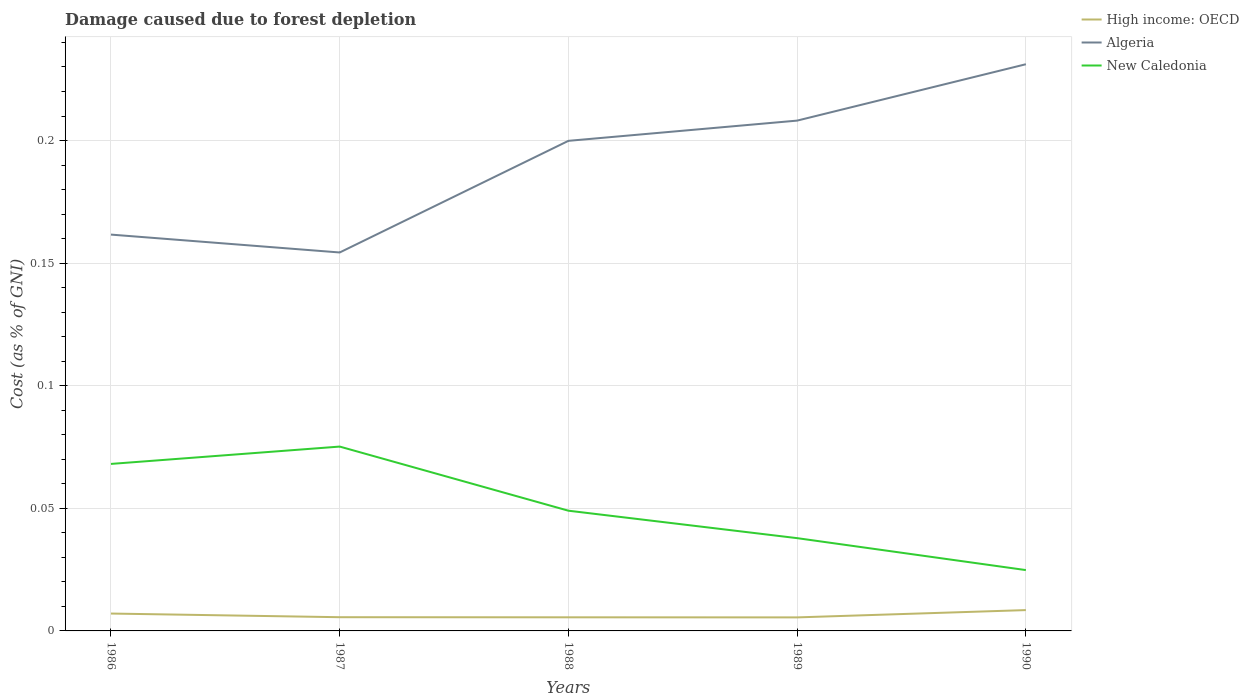Across all years, what is the maximum cost of damage caused due to forest depletion in High income: OECD?
Make the answer very short. 0.01. What is the total cost of damage caused due to forest depletion in High income: OECD in the graph?
Ensure brevity in your answer.  7.520586722561777e-5. What is the difference between the highest and the second highest cost of damage caused due to forest depletion in New Caledonia?
Give a very brief answer. 0.05. How many lines are there?
Keep it short and to the point. 3. How many years are there in the graph?
Provide a short and direct response. 5. What is the difference between two consecutive major ticks on the Y-axis?
Make the answer very short. 0.05. Does the graph contain any zero values?
Provide a succinct answer. No. How many legend labels are there?
Your answer should be very brief. 3. What is the title of the graph?
Offer a very short reply. Damage caused due to forest depletion. What is the label or title of the X-axis?
Make the answer very short. Years. What is the label or title of the Y-axis?
Provide a short and direct response. Cost (as % of GNI). What is the Cost (as % of GNI) of High income: OECD in 1986?
Your response must be concise. 0.01. What is the Cost (as % of GNI) of Algeria in 1986?
Offer a very short reply. 0.16. What is the Cost (as % of GNI) in New Caledonia in 1986?
Your answer should be very brief. 0.07. What is the Cost (as % of GNI) of High income: OECD in 1987?
Provide a succinct answer. 0.01. What is the Cost (as % of GNI) of Algeria in 1987?
Make the answer very short. 0.15. What is the Cost (as % of GNI) of New Caledonia in 1987?
Provide a succinct answer. 0.08. What is the Cost (as % of GNI) in High income: OECD in 1988?
Your answer should be compact. 0.01. What is the Cost (as % of GNI) of Algeria in 1988?
Ensure brevity in your answer.  0.2. What is the Cost (as % of GNI) in New Caledonia in 1988?
Your response must be concise. 0.05. What is the Cost (as % of GNI) of High income: OECD in 1989?
Keep it short and to the point. 0.01. What is the Cost (as % of GNI) of Algeria in 1989?
Ensure brevity in your answer.  0.21. What is the Cost (as % of GNI) of New Caledonia in 1989?
Provide a succinct answer. 0.04. What is the Cost (as % of GNI) of High income: OECD in 1990?
Make the answer very short. 0.01. What is the Cost (as % of GNI) in Algeria in 1990?
Your answer should be compact. 0.23. What is the Cost (as % of GNI) of New Caledonia in 1990?
Give a very brief answer. 0.02. Across all years, what is the maximum Cost (as % of GNI) of High income: OECD?
Provide a succinct answer. 0.01. Across all years, what is the maximum Cost (as % of GNI) in Algeria?
Give a very brief answer. 0.23. Across all years, what is the maximum Cost (as % of GNI) of New Caledonia?
Make the answer very short. 0.08. Across all years, what is the minimum Cost (as % of GNI) in High income: OECD?
Your response must be concise. 0.01. Across all years, what is the minimum Cost (as % of GNI) of Algeria?
Ensure brevity in your answer.  0.15. Across all years, what is the minimum Cost (as % of GNI) of New Caledonia?
Make the answer very short. 0.02. What is the total Cost (as % of GNI) of High income: OECD in the graph?
Make the answer very short. 0.03. What is the total Cost (as % of GNI) of Algeria in the graph?
Offer a very short reply. 0.96. What is the total Cost (as % of GNI) of New Caledonia in the graph?
Give a very brief answer. 0.26. What is the difference between the Cost (as % of GNI) in High income: OECD in 1986 and that in 1987?
Ensure brevity in your answer.  0. What is the difference between the Cost (as % of GNI) of Algeria in 1986 and that in 1987?
Your answer should be very brief. 0.01. What is the difference between the Cost (as % of GNI) in New Caledonia in 1986 and that in 1987?
Ensure brevity in your answer.  -0.01. What is the difference between the Cost (as % of GNI) in High income: OECD in 1986 and that in 1988?
Give a very brief answer. 0. What is the difference between the Cost (as % of GNI) of Algeria in 1986 and that in 1988?
Keep it short and to the point. -0.04. What is the difference between the Cost (as % of GNI) in New Caledonia in 1986 and that in 1988?
Provide a succinct answer. 0.02. What is the difference between the Cost (as % of GNI) in High income: OECD in 1986 and that in 1989?
Give a very brief answer. 0. What is the difference between the Cost (as % of GNI) of Algeria in 1986 and that in 1989?
Offer a very short reply. -0.05. What is the difference between the Cost (as % of GNI) of New Caledonia in 1986 and that in 1989?
Give a very brief answer. 0.03. What is the difference between the Cost (as % of GNI) in High income: OECD in 1986 and that in 1990?
Keep it short and to the point. -0. What is the difference between the Cost (as % of GNI) in Algeria in 1986 and that in 1990?
Give a very brief answer. -0.07. What is the difference between the Cost (as % of GNI) in New Caledonia in 1986 and that in 1990?
Provide a short and direct response. 0.04. What is the difference between the Cost (as % of GNI) of High income: OECD in 1987 and that in 1988?
Make the answer very short. 0. What is the difference between the Cost (as % of GNI) of Algeria in 1987 and that in 1988?
Keep it short and to the point. -0.05. What is the difference between the Cost (as % of GNI) in New Caledonia in 1987 and that in 1988?
Provide a short and direct response. 0.03. What is the difference between the Cost (as % of GNI) in High income: OECD in 1987 and that in 1989?
Your answer should be very brief. 0. What is the difference between the Cost (as % of GNI) of Algeria in 1987 and that in 1989?
Provide a succinct answer. -0.05. What is the difference between the Cost (as % of GNI) in New Caledonia in 1987 and that in 1989?
Keep it short and to the point. 0.04. What is the difference between the Cost (as % of GNI) in High income: OECD in 1987 and that in 1990?
Provide a short and direct response. -0. What is the difference between the Cost (as % of GNI) in Algeria in 1987 and that in 1990?
Your answer should be very brief. -0.08. What is the difference between the Cost (as % of GNI) of New Caledonia in 1987 and that in 1990?
Ensure brevity in your answer.  0.05. What is the difference between the Cost (as % of GNI) of Algeria in 1988 and that in 1989?
Provide a succinct answer. -0.01. What is the difference between the Cost (as % of GNI) in New Caledonia in 1988 and that in 1989?
Your answer should be very brief. 0.01. What is the difference between the Cost (as % of GNI) of High income: OECD in 1988 and that in 1990?
Offer a terse response. -0. What is the difference between the Cost (as % of GNI) of Algeria in 1988 and that in 1990?
Keep it short and to the point. -0.03. What is the difference between the Cost (as % of GNI) in New Caledonia in 1988 and that in 1990?
Your response must be concise. 0.02. What is the difference between the Cost (as % of GNI) in High income: OECD in 1989 and that in 1990?
Your answer should be very brief. -0. What is the difference between the Cost (as % of GNI) of Algeria in 1989 and that in 1990?
Provide a short and direct response. -0.02. What is the difference between the Cost (as % of GNI) in New Caledonia in 1989 and that in 1990?
Provide a succinct answer. 0.01. What is the difference between the Cost (as % of GNI) of High income: OECD in 1986 and the Cost (as % of GNI) of Algeria in 1987?
Provide a short and direct response. -0.15. What is the difference between the Cost (as % of GNI) of High income: OECD in 1986 and the Cost (as % of GNI) of New Caledonia in 1987?
Your answer should be very brief. -0.07. What is the difference between the Cost (as % of GNI) in Algeria in 1986 and the Cost (as % of GNI) in New Caledonia in 1987?
Provide a succinct answer. 0.09. What is the difference between the Cost (as % of GNI) of High income: OECD in 1986 and the Cost (as % of GNI) of Algeria in 1988?
Offer a very short reply. -0.19. What is the difference between the Cost (as % of GNI) in High income: OECD in 1986 and the Cost (as % of GNI) in New Caledonia in 1988?
Keep it short and to the point. -0.04. What is the difference between the Cost (as % of GNI) in Algeria in 1986 and the Cost (as % of GNI) in New Caledonia in 1988?
Your answer should be compact. 0.11. What is the difference between the Cost (as % of GNI) of High income: OECD in 1986 and the Cost (as % of GNI) of Algeria in 1989?
Offer a very short reply. -0.2. What is the difference between the Cost (as % of GNI) in High income: OECD in 1986 and the Cost (as % of GNI) in New Caledonia in 1989?
Your response must be concise. -0.03. What is the difference between the Cost (as % of GNI) of Algeria in 1986 and the Cost (as % of GNI) of New Caledonia in 1989?
Your answer should be compact. 0.12. What is the difference between the Cost (as % of GNI) of High income: OECD in 1986 and the Cost (as % of GNI) of Algeria in 1990?
Make the answer very short. -0.22. What is the difference between the Cost (as % of GNI) in High income: OECD in 1986 and the Cost (as % of GNI) in New Caledonia in 1990?
Keep it short and to the point. -0.02. What is the difference between the Cost (as % of GNI) in Algeria in 1986 and the Cost (as % of GNI) in New Caledonia in 1990?
Offer a very short reply. 0.14. What is the difference between the Cost (as % of GNI) of High income: OECD in 1987 and the Cost (as % of GNI) of Algeria in 1988?
Ensure brevity in your answer.  -0.19. What is the difference between the Cost (as % of GNI) in High income: OECD in 1987 and the Cost (as % of GNI) in New Caledonia in 1988?
Provide a succinct answer. -0.04. What is the difference between the Cost (as % of GNI) in Algeria in 1987 and the Cost (as % of GNI) in New Caledonia in 1988?
Offer a terse response. 0.11. What is the difference between the Cost (as % of GNI) in High income: OECD in 1987 and the Cost (as % of GNI) in Algeria in 1989?
Provide a short and direct response. -0.2. What is the difference between the Cost (as % of GNI) of High income: OECD in 1987 and the Cost (as % of GNI) of New Caledonia in 1989?
Provide a succinct answer. -0.03. What is the difference between the Cost (as % of GNI) of Algeria in 1987 and the Cost (as % of GNI) of New Caledonia in 1989?
Provide a short and direct response. 0.12. What is the difference between the Cost (as % of GNI) in High income: OECD in 1987 and the Cost (as % of GNI) in Algeria in 1990?
Your response must be concise. -0.23. What is the difference between the Cost (as % of GNI) in High income: OECD in 1987 and the Cost (as % of GNI) in New Caledonia in 1990?
Your answer should be compact. -0.02. What is the difference between the Cost (as % of GNI) of Algeria in 1987 and the Cost (as % of GNI) of New Caledonia in 1990?
Make the answer very short. 0.13. What is the difference between the Cost (as % of GNI) of High income: OECD in 1988 and the Cost (as % of GNI) of Algeria in 1989?
Your response must be concise. -0.2. What is the difference between the Cost (as % of GNI) in High income: OECD in 1988 and the Cost (as % of GNI) in New Caledonia in 1989?
Keep it short and to the point. -0.03. What is the difference between the Cost (as % of GNI) in Algeria in 1988 and the Cost (as % of GNI) in New Caledonia in 1989?
Provide a short and direct response. 0.16. What is the difference between the Cost (as % of GNI) of High income: OECD in 1988 and the Cost (as % of GNI) of Algeria in 1990?
Ensure brevity in your answer.  -0.23. What is the difference between the Cost (as % of GNI) in High income: OECD in 1988 and the Cost (as % of GNI) in New Caledonia in 1990?
Ensure brevity in your answer.  -0.02. What is the difference between the Cost (as % of GNI) in Algeria in 1988 and the Cost (as % of GNI) in New Caledonia in 1990?
Your response must be concise. 0.18. What is the difference between the Cost (as % of GNI) in High income: OECD in 1989 and the Cost (as % of GNI) in Algeria in 1990?
Ensure brevity in your answer.  -0.23. What is the difference between the Cost (as % of GNI) of High income: OECD in 1989 and the Cost (as % of GNI) of New Caledonia in 1990?
Give a very brief answer. -0.02. What is the difference between the Cost (as % of GNI) in Algeria in 1989 and the Cost (as % of GNI) in New Caledonia in 1990?
Offer a terse response. 0.18. What is the average Cost (as % of GNI) in High income: OECD per year?
Your answer should be compact. 0.01. What is the average Cost (as % of GNI) in Algeria per year?
Provide a succinct answer. 0.19. What is the average Cost (as % of GNI) of New Caledonia per year?
Provide a succinct answer. 0.05. In the year 1986, what is the difference between the Cost (as % of GNI) of High income: OECD and Cost (as % of GNI) of Algeria?
Offer a terse response. -0.15. In the year 1986, what is the difference between the Cost (as % of GNI) of High income: OECD and Cost (as % of GNI) of New Caledonia?
Ensure brevity in your answer.  -0.06. In the year 1986, what is the difference between the Cost (as % of GNI) of Algeria and Cost (as % of GNI) of New Caledonia?
Ensure brevity in your answer.  0.09. In the year 1987, what is the difference between the Cost (as % of GNI) in High income: OECD and Cost (as % of GNI) in Algeria?
Ensure brevity in your answer.  -0.15. In the year 1987, what is the difference between the Cost (as % of GNI) of High income: OECD and Cost (as % of GNI) of New Caledonia?
Give a very brief answer. -0.07. In the year 1987, what is the difference between the Cost (as % of GNI) in Algeria and Cost (as % of GNI) in New Caledonia?
Offer a very short reply. 0.08. In the year 1988, what is the difference between the Cost (as % of GNI) of High income: OECD and Cost (as % of GNI) of Algeria?
Your answer should be very brief. -0.19. In the year 1988, what is the difference between the Cost (as % of GNI) in High income: OECD and Cost (as % of GNI) in New Caledonia?
Your response must be concise. -0.04. In the year 1988, what is the difference between the Cost (as % of GNI) in Algeria and Cost (as % of GNI) in New Caledonia?
Your response must be concise. 0.15. In the year 1989, what is the difference between the Cost (as % of GNI) in High income: OECD and Cost (as % of GNI) in Algeria?
Give a very brief answer. -0.2. In the year 1989, what is the difference between the Cost (as % of GNI) of High income: OECD and Cost (as % of GNI) of New Caledonia?
Make the answer very short. -0.03. In the year 1989, what is the difference between the Cost (as % of GNI) of Algeria and Cost (as % of GNI) of New Caledonia?
Your answer should be very brief. 0.17. In the year 1990, what is the difference between the Cost (as % of GNI) in High income: OECD and Cost (as % of GNI) in Algeria?
Ensure brevity in your answer.  -0.22. In the year 1990, what is the difference between the Cost (as % of GNI) of High income: OECD and Cost (as % of GNI) of New Caledonia?
Make the answer very short. -0.02. In the year 1990, what is the difference between the Cost (as % of GNI) of Algeria and Cost (as % of GNI) of New Caledonia?
Keep it short and to the point. 0.21. What is the ratio of the Cost (as % of GNI) of High income: OECD in 1986 to that in 1987?
Your response must be concise. 1.27. What is the ratio of the Cost (as % of GNI) of Algeria in 1986 to that in 1987?
Give a very brief answer. 1.05. What is the ratio of the Cost (as % of GNI) of New Caledonia in 1986 to that in 1987?
Keep it short and to the point. 0.91. What is the ratio of the Cost (as % of GNI) of High income: OECD in 1986 to that in 1988?
Your response must be concise. 1.28. What is the ratio of the Cost (as % of GNI) of Algeria in 1986 to that in 1988?
Make the answer very short. 0.81. What is the ratio of the Cost (as % of GNI) in New Caledonia in 1986 to that in 1988?
Ensure brevity in your answer.  1.39. What is the ratio of the Cost (as % of GNI) of High income: OECD in 1986 to that in 1989?
Your answer should be compact. 1.28. What is the ratio of the Cost (as % of GNI) in Algeria in 1986 to that in 1989?
Your response must be concise. 0.78. What is the ratio of the Cost (as % of GNI) of New Caledonia in 1986 to that in 1989?
Keep it short and to the point. 1.8. What is the ratio of the Cost (as % of GNI) in High income: OECD in 1986 to that in 1990?
Keep it short and to the point. 0.83. What is the ratio of the Cost (as % of GNI) in Algeria in 1986 to that in 1990?
Your response must be concise. 0.7. What is the ratio of the Cost (as % of GNI) of New Caledonia in 1986 to that in 1990?
Your answer should be very brief. 2.75. What is the ratio of the Cost (as % of GNI) of High income: OECD in 1987 to that in 1988?
Provide a short and direct response. 1.01. What is the ratio of the Cost (as % of GNI) of Algeria in 1987 to that in 1988?
Your answer should be compact. 0.77. What is the ratio of the Cost (as % of GNI) in New Caledonia in 1987 to that in 1988?
Offer a terse response. 1.53. What is the ratio of the Cost (as % of GNI) of High income: OECD in 1987 to that in 1989?
Offer a terse response. 1.01. What is the ratio of the Cost (as % of GNI) in Algeria in 1987 to that in 1989?
Offer a terse response. 0.74. What is the ratio of the Cost (as % of GNI) of New Caledonia in 1987 to that in 1989?
Provide a short and direct response. 1.99. What is the ratio of the Cost (as % of GNI) in High income: OECD in 1987 to that in 1990?
Make the answer very short. 0.66. What is the ratio of the Cost (as % of GNI) in Algeria in 1987 to that in 1990?
Give a very brief answer. 0.67. What is the ratio of the Cost (as % of GNI) of New Caledonia in 1987 to that in 1990?
Ensure brevity in your answer.  3.03. What is the ratio of the Cost (as % of GNI) of High income: OECD in 1988 to that in 1989?
Give a very brief answer. 1.01. What is the ratio of the Cost (as % of GNI) in Algeria in 1988 to that in 1989?
Offer a very short reply. 0.96. What is the ratio of the Cost (as % of GNI) of New Caledonia in 1988 to that in 1989?
Provide a succinct answer. 1.3. What is the ratio of the Cost (as % of GNI) of High income: OECD in 1988 to that in 1990?
Provide a succinct answer. 0.65. What is the ratio of the Cost (as % of GNI) in Algeria in 1988 to that in 1990?
Your response must be concise. 0.86. What is the ratio of the Cost (as % of GNI) of New Caledonia in 1988 to that in 1990?
Make the answer very short. 1.98. What is the ratio of the Cost (as % of GNI) of High income: OECD in 1989 to that in 1990?
Ensure brevity in your answer.  0.65. What is the ratio of the Cost (as % of GNI) of Algeria in 1989 to that in 1990?
Provide a succinct answer. 0.9. What is the ratio of the Cost (as % of GNI) in New Caledonia in 1989 to that in 1990?
Make the answer very short. 1.52. What is the difference between the highest and the second highest Cost (as % of GNI) of High income: OECD?
Ensure brevity in your answer.  0. What is the difference between the highest and the second highest Cost (as % of GNI) of Algeria?
Offer a terse response. 0.02. What is the difference between the highest and the second highest Cost (as % of GNI) in New Caledonia?
Provide a short and direct response. 0.01. What is the difference between the highest and the lowest Cost (as % of GNI) in High income: OECD?
Make the answer very short. 0. What is the difference between the highest and the lowest Cost (as % of GNI) of Algeria?
Your response must be concise. 0.08. What is the difference between the highest and the lowest Cost (as % of GNI) of New Caledonia?
Provide a short and direct response. 0.05. 